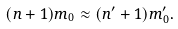<formula> <loc_0><loc_0><loc_500><loc_500>( n + 1 ) m _ { 0 } \approx ( n ^ { \prime } + 1 ) m ^ { \prime } _ { 0 } .</formula> 